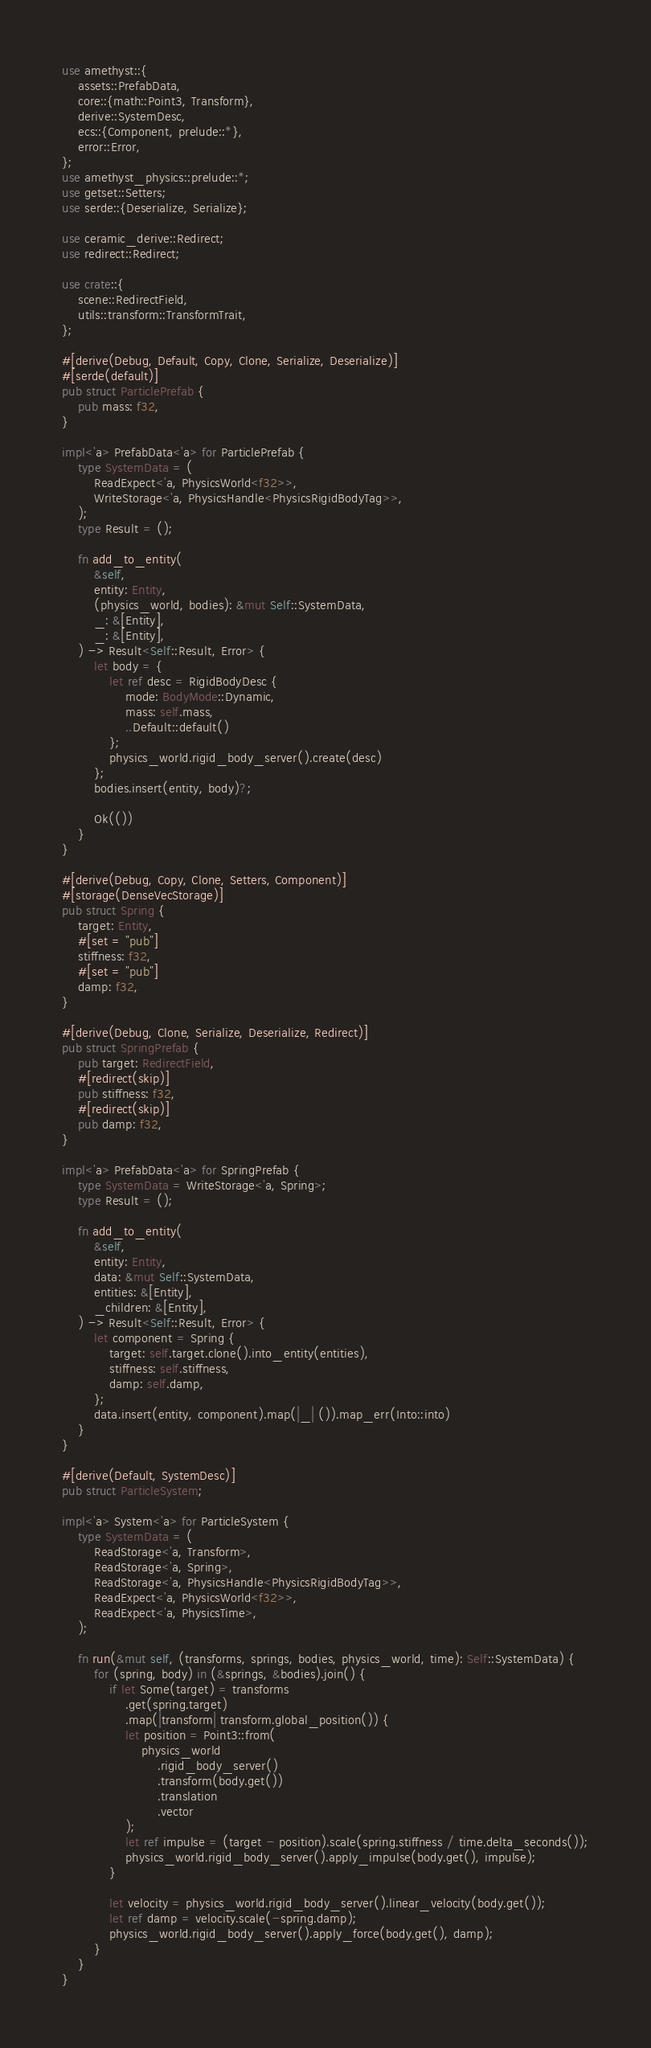<code> <loc_0><loc_0><loc_500><loc_500><_Rust_>use amethyst::{
    assets::PrefabData,
    core::{math::Point3, Transform},
    derive::SystemDesc,
    ecs::{Component, prelude::*},
    error::Error,
};
use amethyst_physics::prelude::*;
use getset::Setters;
use serde::{Deserialize, Serialize};

use ceramic_derive::Redirect;
use redirect::Redirect;

use crate::{
    scene::RedirectField,
    utils::transform::TransformTrait,
};

#[derive(Debug, Default, Copy, Clone, Serialize, Deserialize)]
#[serde(default)]
pub struct ParticlePrefab {
    pub mass: f32,
}

impl<'a> PrefabData<'a> for ParticlePrefab {
    type SystemData = (
        ReadExpect<'a, PhysicsWorld<f32>>,
        WriteStorage<'a, PhysicsHandle<PhysicsRigidBodyTag>>,
    );
    type Result = ();

    fn add_to_entity(
        &self,
        entity: Entity,
        (physics_world, bodies): &mut Self::SystemData,
        _: &[Entity],
        _: &[Entity],
    ) -> Result<Self::Result, Error> {
        let body = {
            let ref desc = RigidBodyDesc {
                mode: BodyMode::Dynamic,
                mass: self.mass,
                ..Default::default()
            };
            physics_world.rigid_body_server().create(desc)
        };
        bodies.insert(entity, body)?;

        Ok(())
    }
}

#[derive(Debug, Copy, Clone, Setters, Component)]
#[storage(DenseVecStorage)]
pub struct Spring {
    target: Entity,
    #[set = "pub"]
    stiffness: f32,
    #[set = "pub"]
    damp: f32,
}

#[derive(Debug, Clone, Serialize, Deserialize, Redirect)]
pub struct SpringPrefab {
    pub target: RedirectField,
    #[redirect(skip)]
    pub stiffness: f32,
    #[redirect(skip)]
    pub damp: f32,
}

impl<'a> PrefabData<'a> for SpringPrefab {
    type SystemData = WriteStorage<'a, Spring>;
    type Result = ();

    fn add_to_entity(
        &self,
        entity: Entity,
        data: &mut Self::SystemData,
        entities: &[Entity],
        _children: &[Entity],
    ) -> Result<Self::Result, Error> {
        let component = Spring {
            target: self.target.clone().into_entity(entities),
            stiffness: self.stiffness,
            damp: self.damp,
        };
        data.insert(entity, component).map(|_| ()).map_err(Into::into)
    }
}

#[derive(Default, SystemDesc)]
pub struct ParticleSystem;

impl<'a> System<'a> for ParticleSystem {
    type SystemData = (
        ReadStorage<'a, Transform>,
        ReadStorage<'a, Spring>,
        ReadStorage<'a, PhysicsHandle<PhysicsRigidBodyTag>>,
        ReadExpect<'a, PhysicsWorld<f32>>,
        ReadExpect<'a, PhysicsTime>,
    );

    fn run(&mut self, (transforms, springs, bodies, physics_world, time): Self::SystemData) {
        for (spring, body) in (&springs, &bodies).join() {
            if let Some(target) = transforms
                .get(spring.target)
                .map(|transform| transform.global_position()) {
                let position = Point3::from(
                    physics_world
                        .rigid_body_server()
                        .transform(body.get())
                        .translation
                        .vector
                );
                let ref impulse = (target - position).scale(spring.stiffness / time.delta_seconds());
                physics_world.rigid_body_server().apply_impulse(body.get(), impulse);
            }

            let velocity = physics_world.rigid_body_server().linear_velocity(body.get());
            let ref damp = velocity.scale(-spring.damp);
            physics_world.rigid_body_server().apply_force(body.get(), damp);
        }
    }
}</code> 